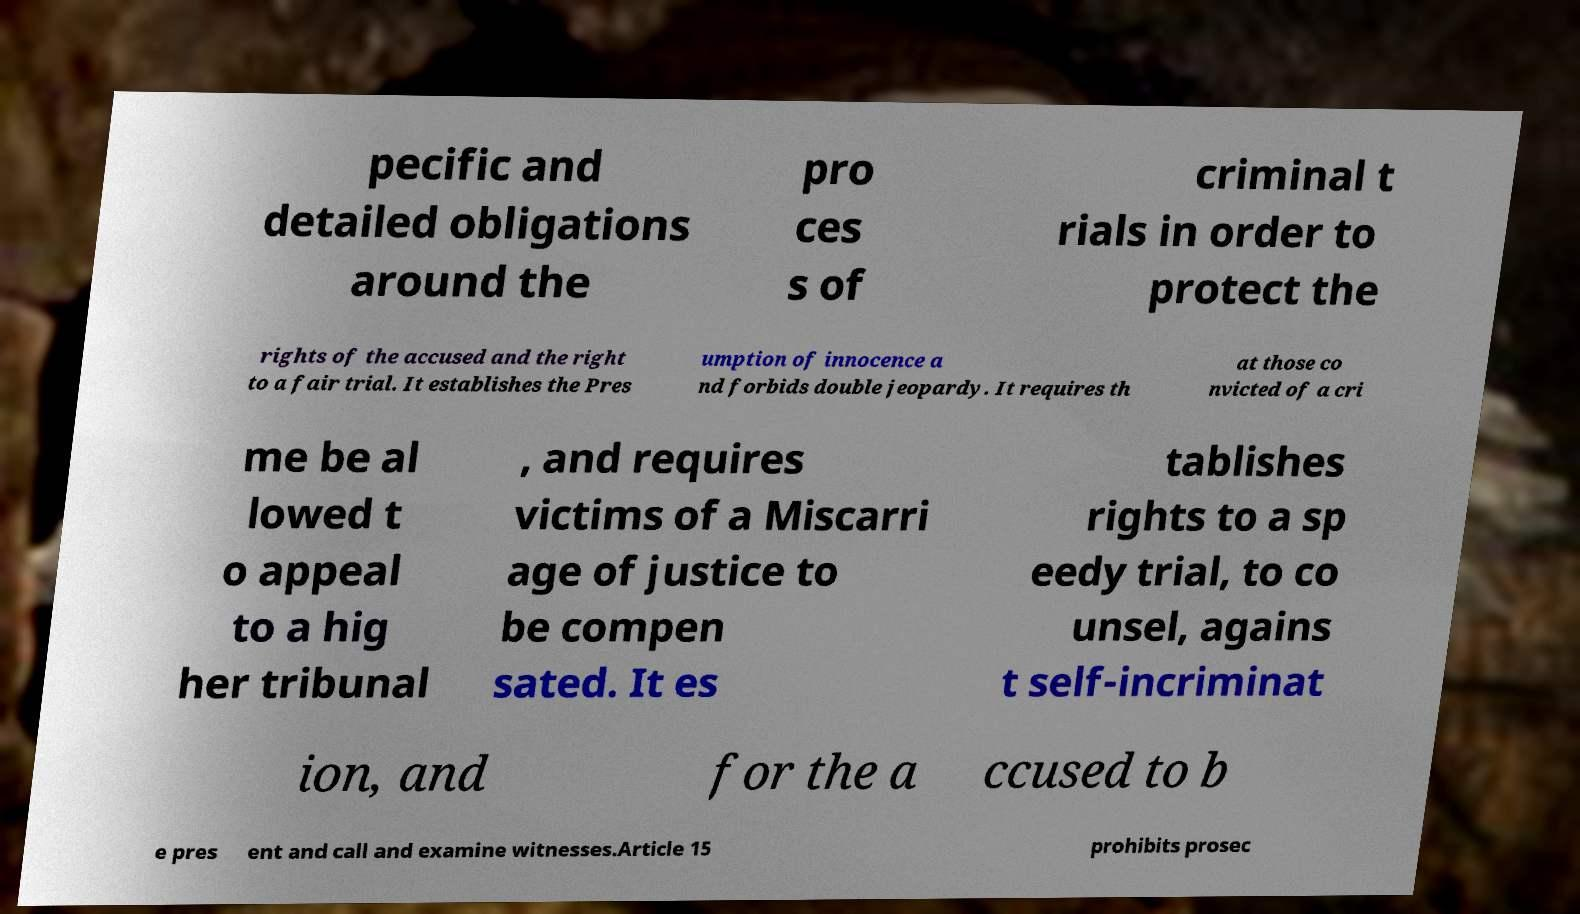For documentation purposes, I need the text within this image transcribed. Could you provide that? pecific and detailed obligations around the pro ces s of criminal t rials in order to protect the rights of the accused and the right to a fair trial. It establishes the Pres umption of innocence a nd forbids double jeopardy. It requires th at those co nvicted of a cri me be al lowed t o appeal to a hig her tribunal , and requires victims of a Miscarri age of justice to be compen sated. It es tablishes rights to a sp eedy trial, to co unsel, agains t self-incriminat ion, and for the a ccused to b e pres ent and call and examine witnesses.Article 15 prohibits prosec 